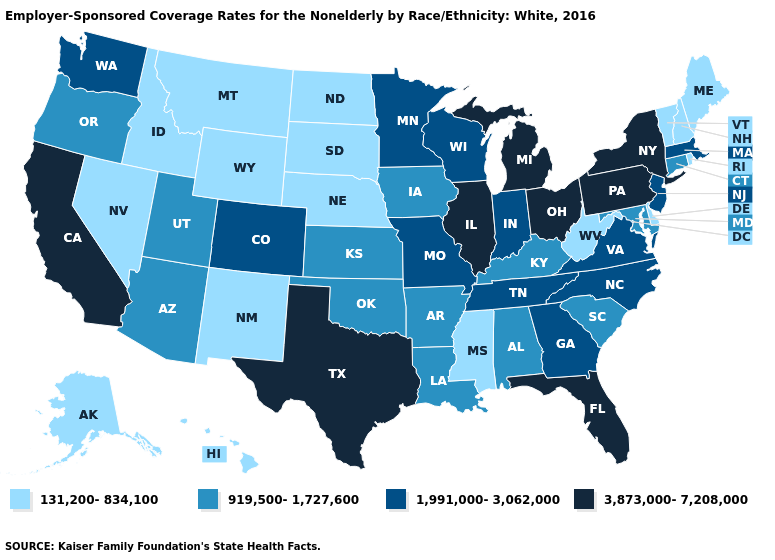What is the highest value in the Northeast ?
Short answer required. 3,873,000-7,208,000. Does Pennsylvania have the highest value in the USA?
Write a very short answer. Yes. What is the value of Arkansas?
Concise answer only. 919,500-1,727,600. Which states have the lowest value in the MidWest?
Write a very short answer. Nebraska, North Dakota, South Dakota. Name the states that have a value in the range 1,991,000-3,062,000?
Give a very brief answer. Colorado, Georgia, Indiana, Massachusetts, Minnesota, Missouri, New Jersey, North Carolina, Tennessee, Virginia, Washington, Wisconsin. Which states have the lowest value in the West?
Keep it brief. Alaska, Hawaii, Idaho, Montana, Nevada, New Mexico, Wyoming. Which states hav the highest value in the South?
Concise answer only. Florida, Texas. Does Pennsylvania have the highest value in the Northeast?
Short answer required. Yes. Among the states that border California , does Nevada have the highest value?
Give a very brief answer. No. What is the value of Florida?
Answer briefly. 3,873,000-7,208,000. What is the value of North Carolina?
Keep it brief. 1,991,000-3,062,000. Name the states that have a value in the range 919,500-1,727,600?
Short answer required. Alabama, Arizona, Arkansas, Connecticut, Iowa, Kansas, Kentucky, Louisiana, Maryland, Oklahoma, Oregon, South Carolina, Utah. What is the value of Connecticut?
Answer briefly. 919,500-1,727,600. Name the states that have a value in the range 1,991,000-3,062,000?
Short answer required. Colorado, Georgia, Indiana, Massachusetts, Minnesota, Missouri, New Jersey, North Carolina, Tennessee, Virginia, Washington, Wisconsin. Among the states that border Georgia , does Tennessee have the lowest value?
Short answer required. No. 